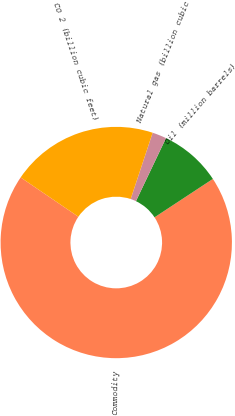<chart> <loc_0><loc_0><loc_500><loc_500><pie_chart><fcel>Commodity<fcel>Oil (million barrels)<fcel>Natural gas (billion cubic<fcel>CO 2 (billion cubic feet)<nl><fcel>68.78%<fcel>8.66%<fcel>1.98%<fcel>20.58%<nl></chart> 